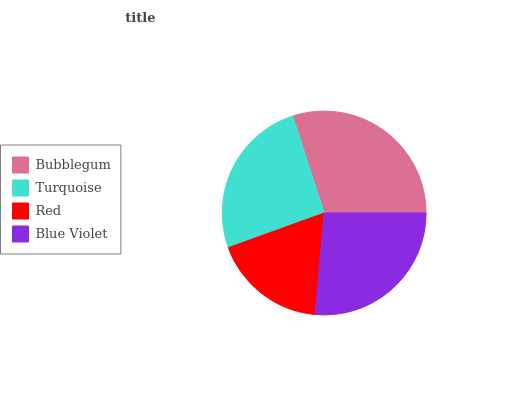Is Red the minimum?
Answer yes or no. Yes. Is Bubblegum the maximum?
Answer yes or no. Yes. Is Turquoise the minimum?
Answer yes or no. No. Is Turquoise the maximum?
Answer yes or no. No. Is Bubblegum greater than Turquoise?
Answer yes or no. Yes. Is Turquoise less than Bubblegum?
Answer yes or no. Yes. Is Turquoise greater than Bubblegum?
Answer yes or no. No. Is Bubblegum less than Turquoise?
Answer yes or no. No. Is Blue Violet the high median?
Answer yes or no. Yes. Is Turquoise the low median?
Answer yes or no. Yes. Is Bubblegum the high median?
Answer yes or no. No. Is Blue Violet the low median?
Answer yes or no. No. 